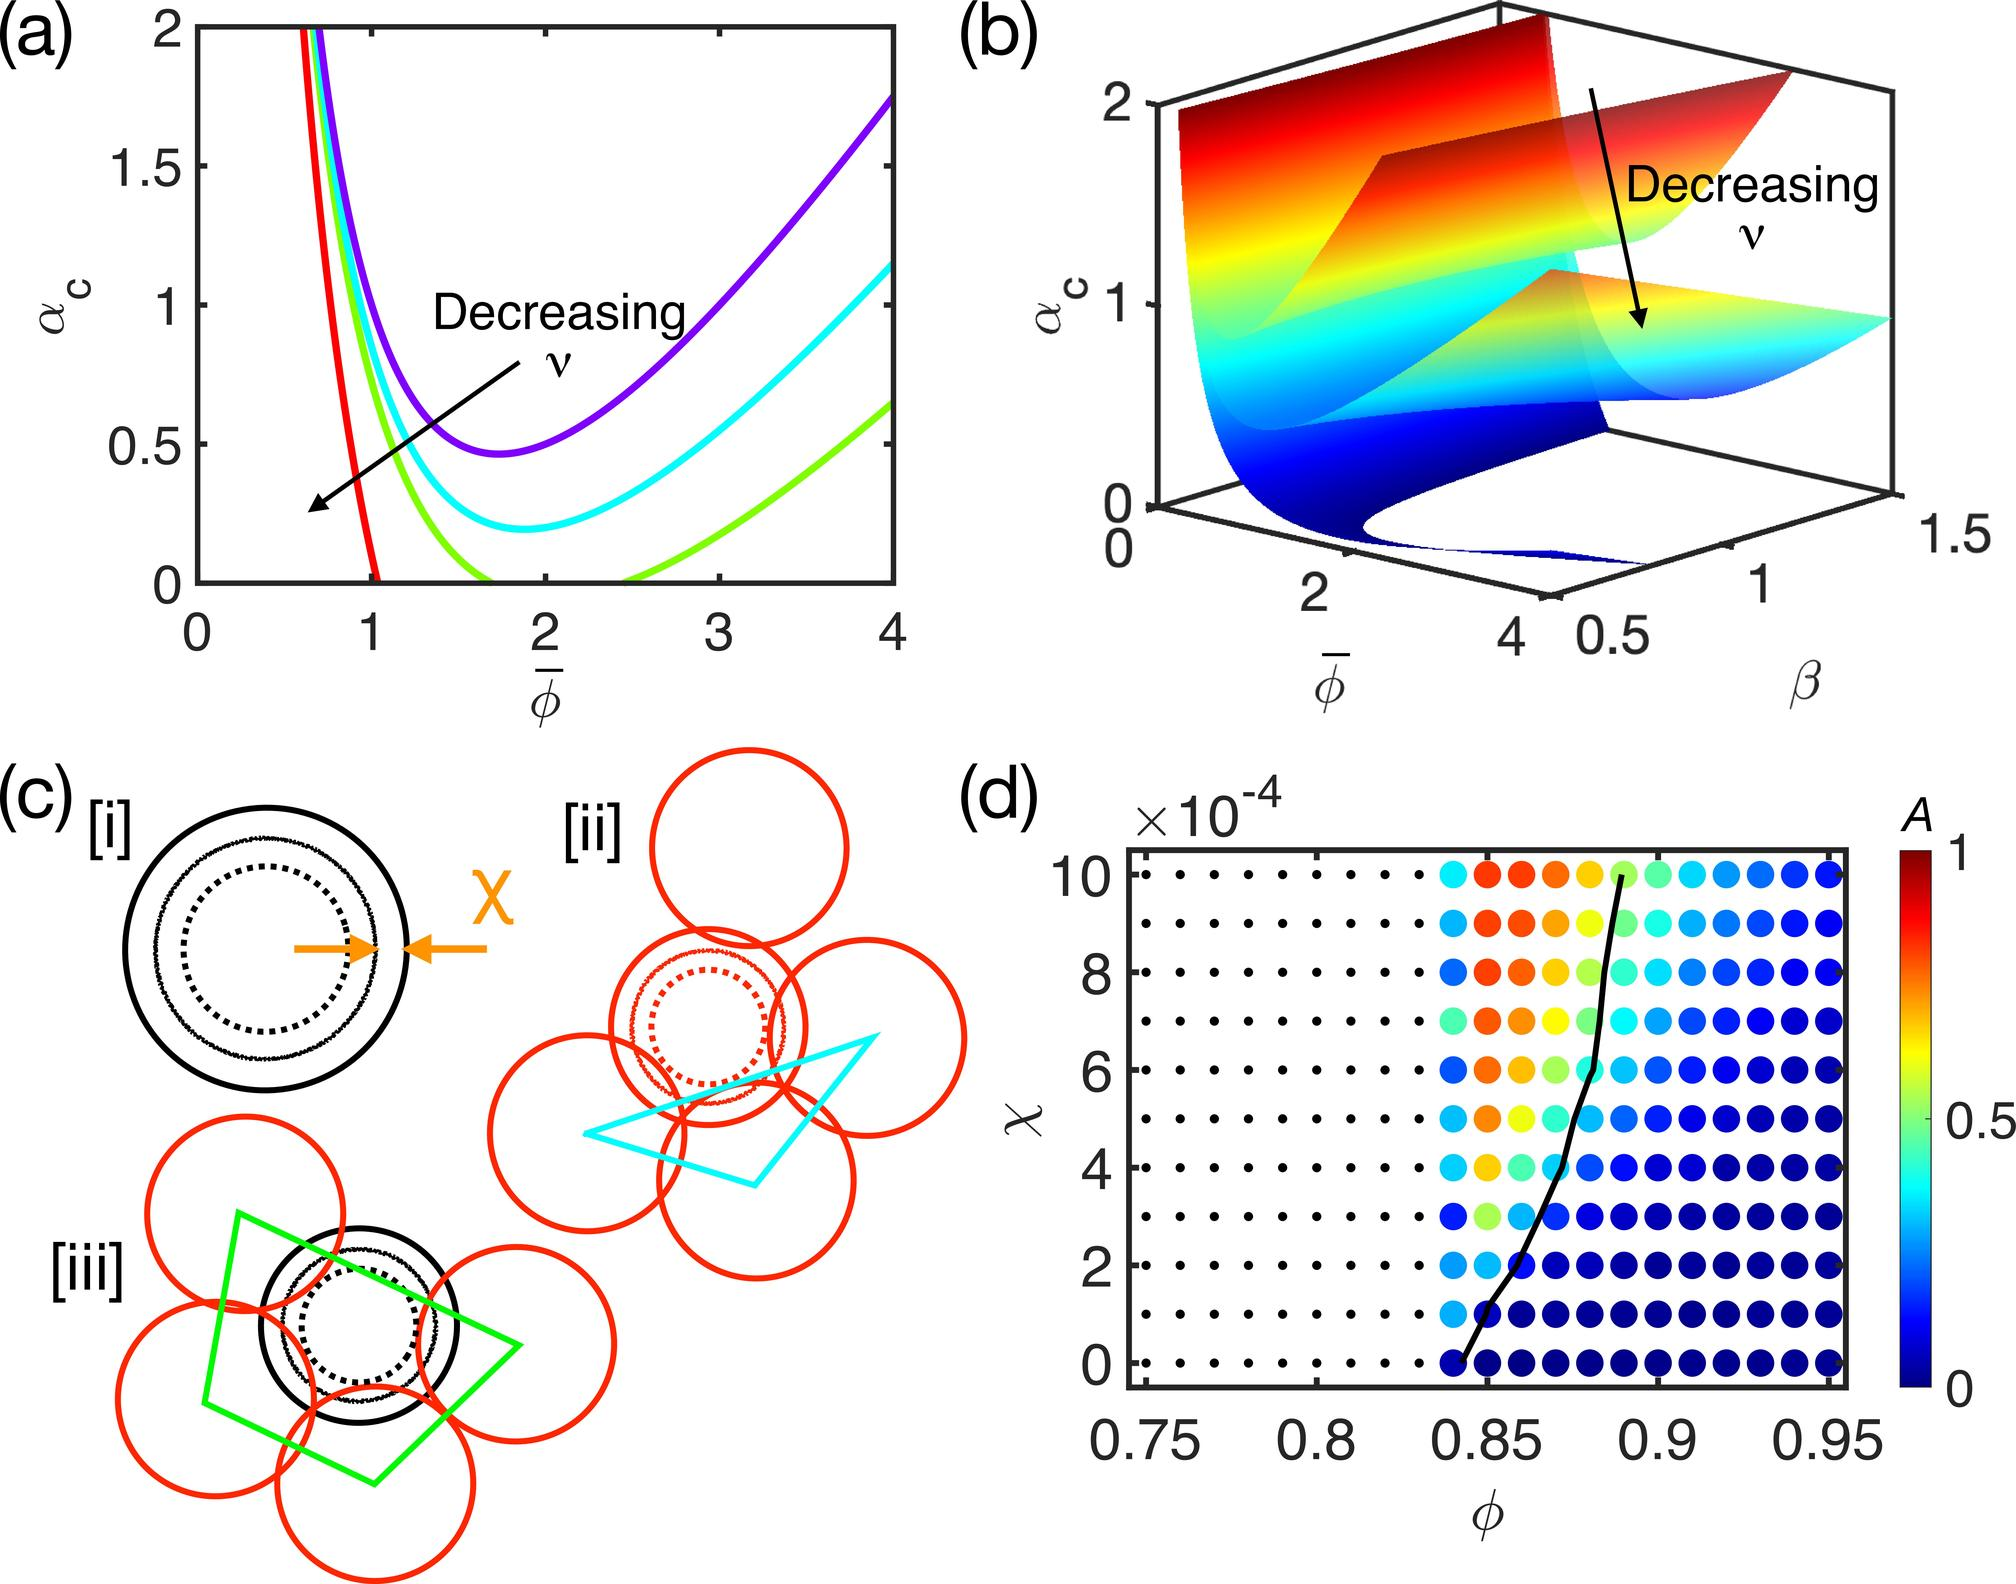How do different parts of the graph correlate with mathematical principles or theories? The different parts of this graph, especially as seen in the color gradient and the shape of the curve, often correspond to specific mathematical concepts such as bifurcation points or stability thresholds. For instance, abrupt changes in color might denote transitions between stable and unstable regimes, commonly modeled in dynamical systems and differential equations. The clear divisions in the color spectrum could illustrate thresholds beyond which the behavior of variable A fundamentally changes its dynamics, potentially implying a mathematical concept like 'catastrophe theory,' which deals with small changes in certain parameters causing sudden shifts in system behavior. 